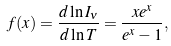<formula> <loc_0><loc_0><loc_500><loc_500>f ( x ) = \frac { d \ln { I _ { \nu } } } { d \ln { T } } = \frac { x e ^ { x } } { e ^ { x } - 1 } ,</formula> 